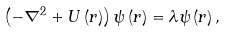Convert formula to latex. <formula><loc_0><loc_0><loc_500><loc_500>\left ( - \nabla ^ { 2 } + U \left ( r \right ) \right ) \psi \left ( r \right ) = \lambda \psi \left ( r \right ) ,</formula> 